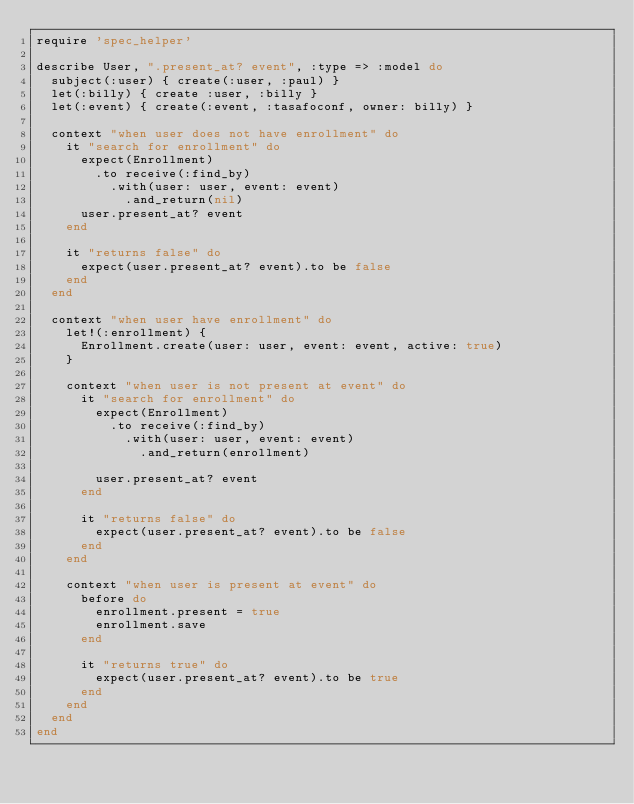Convert code to text. <code><loc_0><loc_0><loc_500><loc_500><_Ruby_>require 'spec_helper'

describe User, ".present_at? event", :type => :model do
  subject(:user) { create(:user, :paul) }
  let(:billy) { create :user, :billy }
  let(:event) { create(:event, :tasafoconf, owner: billy) }

  context "when user does not have enrollment" do
    it "search for enrollment" do
      expect(Enrollment)
        .to receive(:find_by)
          .with(user: user, event: event)
            .and_return(nil)
      user.present_at? event
    end

    it "returns false" do
      expect(user.present_at? event).to be false
    end
  end

  context "when user have enrollment" do
    let!(:enrollment) {
      Enrollment.create(user: user, event: event, active: true)
    }

    context "when user is not present at event" do
      it "search for enrollment" do
        expect(Enrollment)
          .to receive(:find_by)
            .with(user: user, event: event)
              .and_return(enrollment)

        user.present_at? event
      end

      it "returns false" do
        expect(user.present_at? event).to be false
      end
    end

    context "when user is present at event" do
      before do
        enrollment.present = true
        enrollment.save
      end

      it "returns true" do
        expect(user.present_at? event).to be true
      end
    end
  end
end</code> 